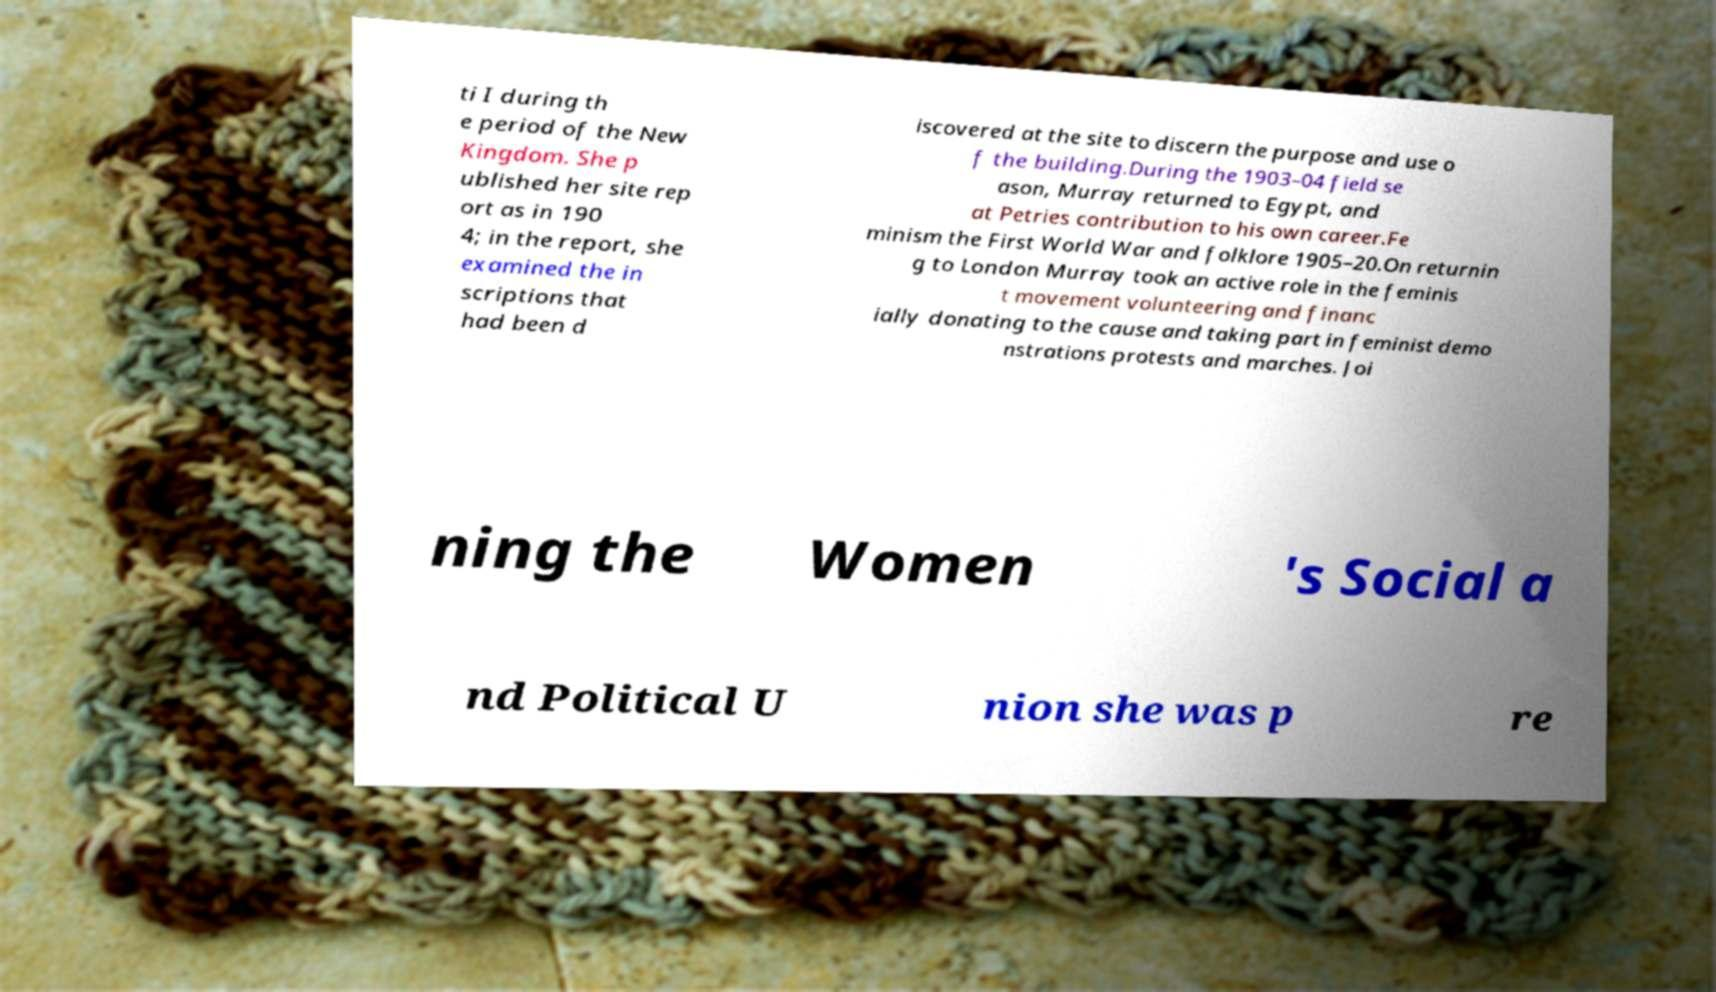Could you assist in decoding the text presented in this image and type it out clearly? ti I during th e period of the New Kingdom. She p ublished her site rep ort as in 190 4; in the report, she examined the in scriptions that had been d iscovered at the site to discern the purpose and use o f the building.During the 1903–04 field se ason, Murray returned to Egypt, and at Petries contribution to his own career.Fe minism the First World War and folklore 1905–20.On returnin g to London Murray took an active role in the feminis t movement volunteering and financ ially donating to the cause and taking part in feminist demo nstrations protests and marches. Joi ning the Women 's Social a nd Political U nion she was p re 